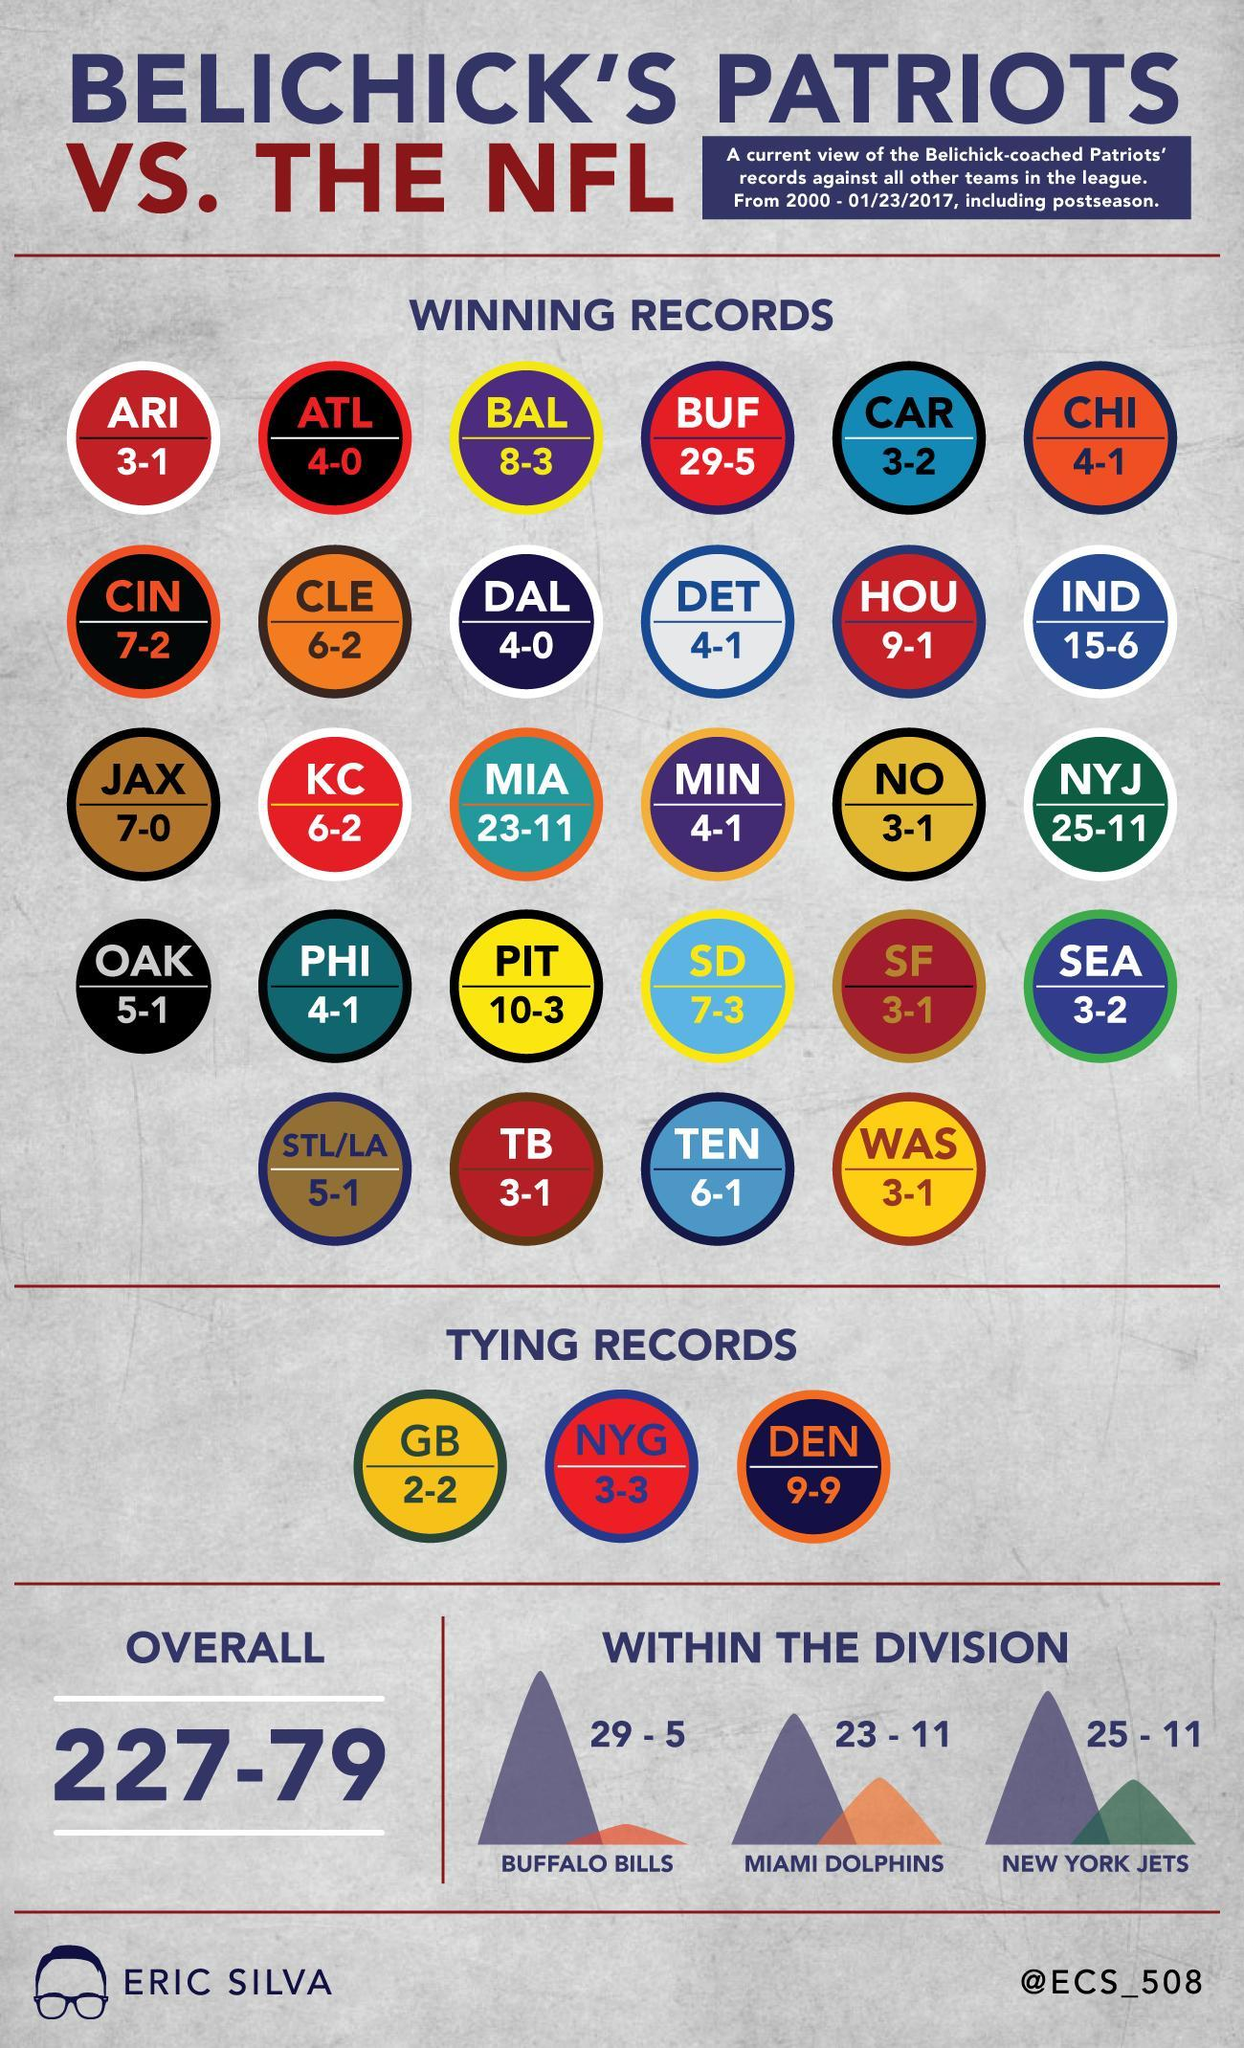Which teams that played against the Patriots in matches were the scored of Patriots was more than 20 points?
Answer the question with a short phrase. Buffalo Bills, Miami Dolphins, New York Jets In how many games did the Patriots score points less than 10? 23 